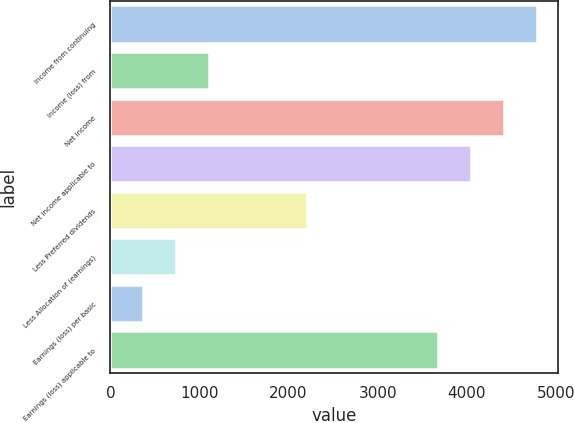<chart> <loc_0><loc_0><loc_500><loc_500><bar_chart><fcel>Income from continuing<fcel>Income (loss) from<fcel>Net income<fcel>Net income applicable to<fcel>Less Preferred dividends<fcel>Less Allocation of (earnings)<fcel>Earnings (loss) per basic<fcel>Earnings (loss) applicable to<nl><fcel>4784.82<fcel>1105.42<fcel>4416.88<fcel>4048.94<fcel>2209.24<fcel>737.48<fcel>369.54<fcel>3681<nl></chart> 